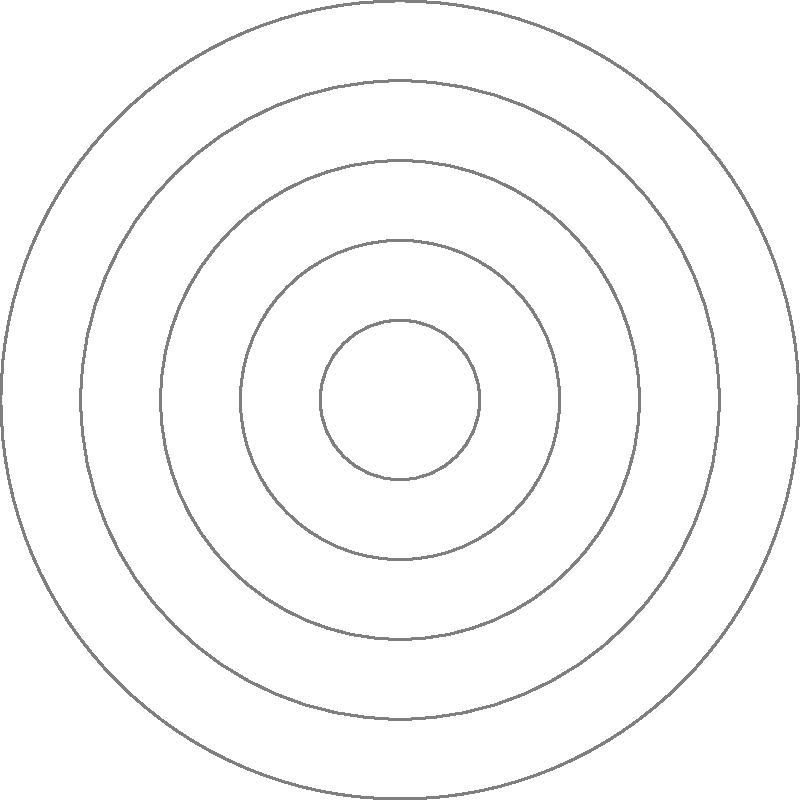In a network latency analysis, three servers A, B, and C are represented in polar coordinates with respect to a central hub O. Server A is at $(3, \frac{\pi}{6})$, B at $(5, \frac{\pi}{3})$, and C at $(4, \frac{2\pi}{3})$. The radial distance represents latency in milliseconds, and the angular coordinate represents the geographical direction. What is the total network latency (in milliseconds) for a data packet that travels from A to B to C and back to A? To solve this problem, we need to calculate the distances between the servers and sum them up. We'll use the formula for distance between two points in polar coordinates:

$d = \sqrt{r_1^2 + r_2^2 - 2r_1r_2\cos(\theta_2 - \theta_1)}$

Step 1: Calculate distance from A to B
$d_{AB} = \sqrt{3^2 + 5^2 - 2(3)(5)\cos(\frac{\pi}{3} - \frac{\pi}{6})}$
$= \sqrt{9 + 25 - 30\cos(\frac{\pi}{6})}$
$= \sqrt{34 - 30(\frac{\sqrt{3}}{2})} \approx 3.606$ ms

Step 2: Calculate distance from B to C
$d_{BC} = \sqrt{5^2 + 4^2 - 2(5)(4)\cos(\frac{2\pi}{3} - \frac{\pi}{3})}$
$= \sqrt{25 + 16 - 40\cos(\frac{\pi}{3})}$
$= \sqrt{41 - 40(\frac{1}{2})} = \sqrt{21} \approx 4.583$ ms

Step 3: Calculate distance from C to A
$d_{CA} = \sqrt{4^2 + 3^2 - 2(4)(3)\cos(\frac{\pi}{6} - \frac{2\pi}{3})}$
$= \sqrt{16 + 9 - 24\cos(-\frac{\pi}{2})}$
$= \sqrt{25} = 5$ ms

Step 4: Sum up all distances
Total latency = $d_{AB} + d_{BC} + d_{CA}$
$\approx 3.606 + 4.583 + 5 = 13.189$ ms
Answer: 13.189 ms 